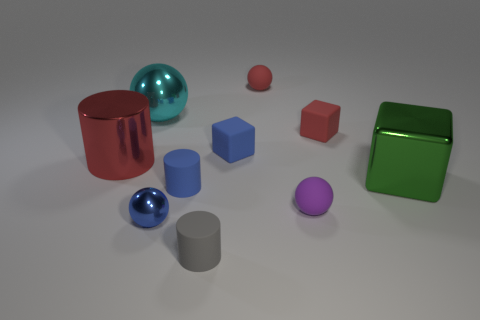How many blue matte objects have the same shape as the green metal object?
Give a very brief answer. 1. What is the material of the blue cube?
Give a very brief answer. Rubber. Is the number of red metal cylinders behind the cyan metallic sphere the same as the number of small blue matte things?
Provide a succinct answer. No. What is the shape of the gray object that is the same size as the purple matte sphere?
Make the answer very short. Cylinder. There is a big red metallic cylinder to the left of the large cyan ball; is there a object behind it?
Keep it short and to the point. Yes. How many small objects are cyan things or rubber objects?
Your answer should be compact. 6. Is there a red matte ball that has the same size as the blue metal sphere?
Your answer should be very brief. Yes. How many shiny objects are purple balls or tiny blue objects?
Offer a very short reply. 1. How many small cylinders are there?
Make the answer very short. 2. Are the big thing behind the small blue cube and the small cylinder that is behind the tiny blue shiny ball made of the same material?
Offer a very short reply. No. 